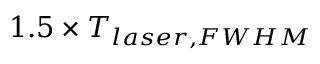<formula> <loc_0><loc_0><loc_500><loc_500>1 . 5 \times T _ { l a s e r , F W H M }</formula> 